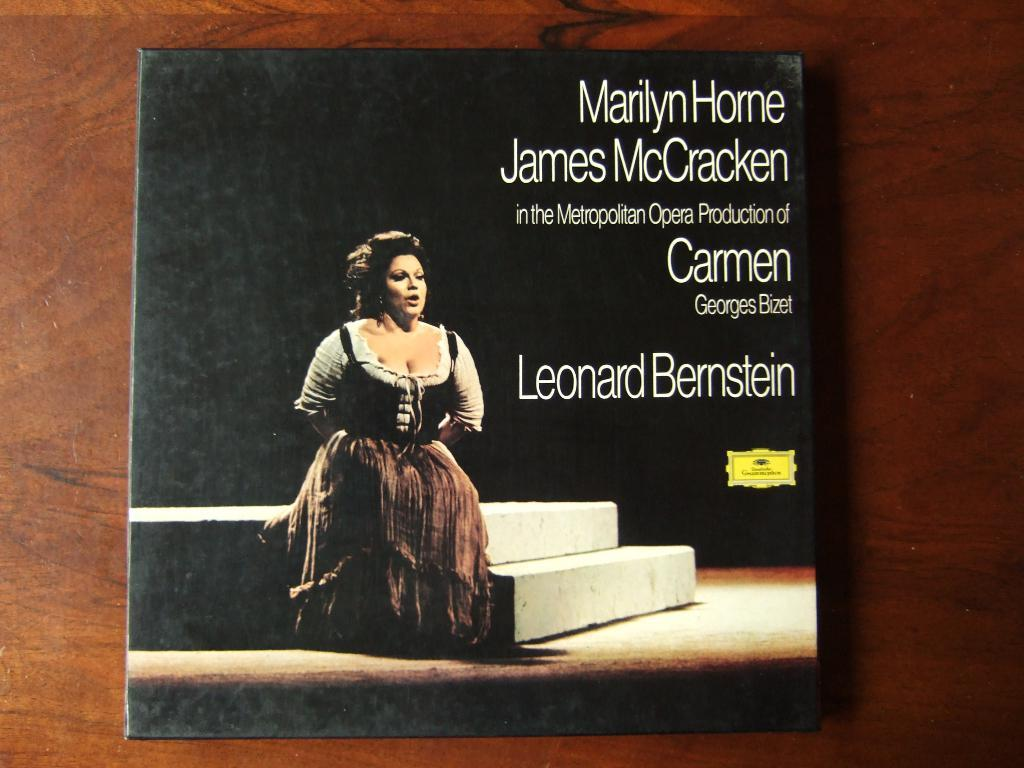<image>
Render a clear and concise summary of the photo. A record cover for an opera titled Carmen. 